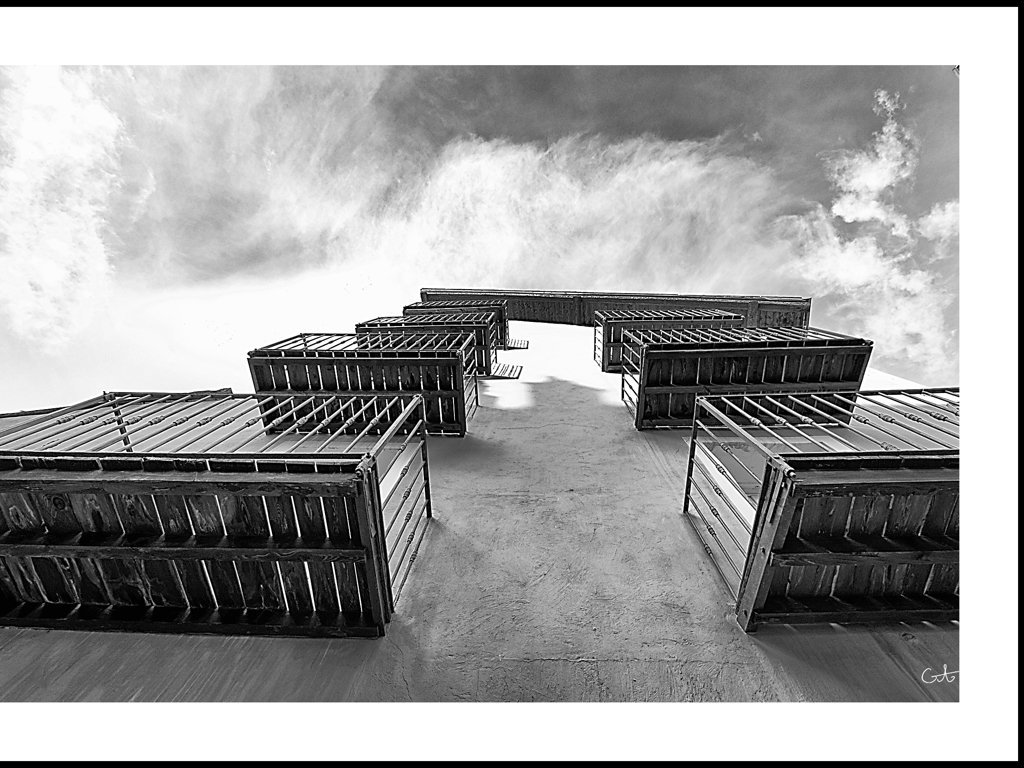Imagine this building is part of a larger cityscape, how would you describe its potential location? If this building were part of a larger cityscape, I would describe its potential location as being in a modern, urban environment, likely within a district of commercial or cultural significance due to its bold design. The building would stand out in the skyline, perhaps as an iconic feature among more traditional structures. 